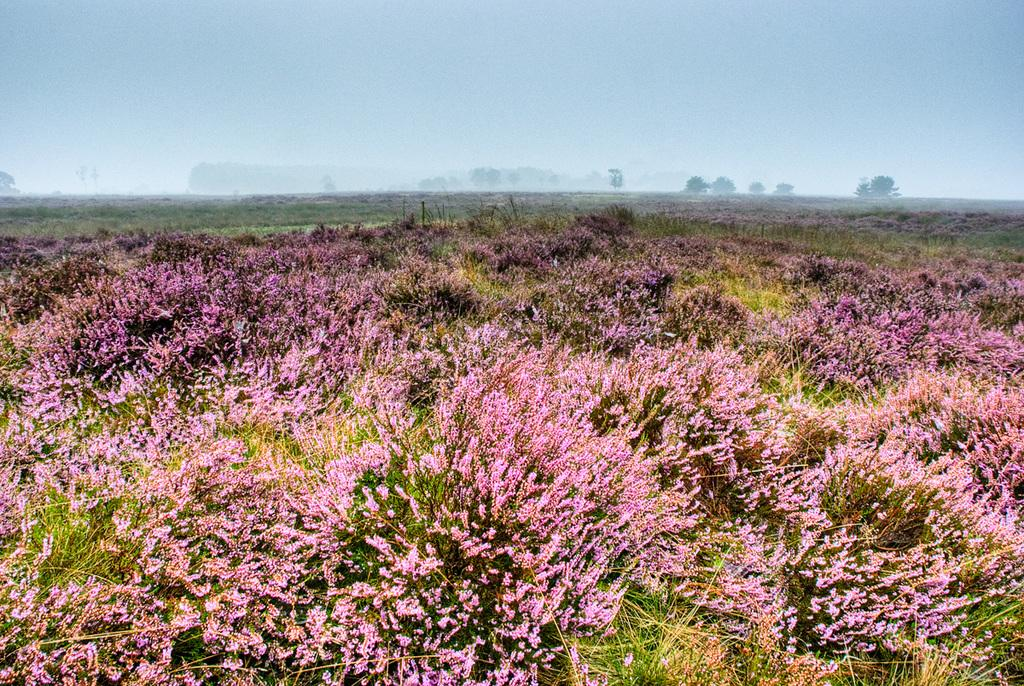What is located in the foreground of the image? There are flowers in the foreground of the image. What can be seen in the background of the image? There are trees in the background of the image. What is visible above the trees in the image? The sky is visible in the image. What can be observed in the sky? Clouds are present in the sky. What type of hope can be seen growing among the flowers in the image? There is no indication of hope in the image; it simply features flowers in the foreground. What is the smell of the flowers in the image? The image is visual, and there is no way to determine the smell of the flowers from the image alone. 